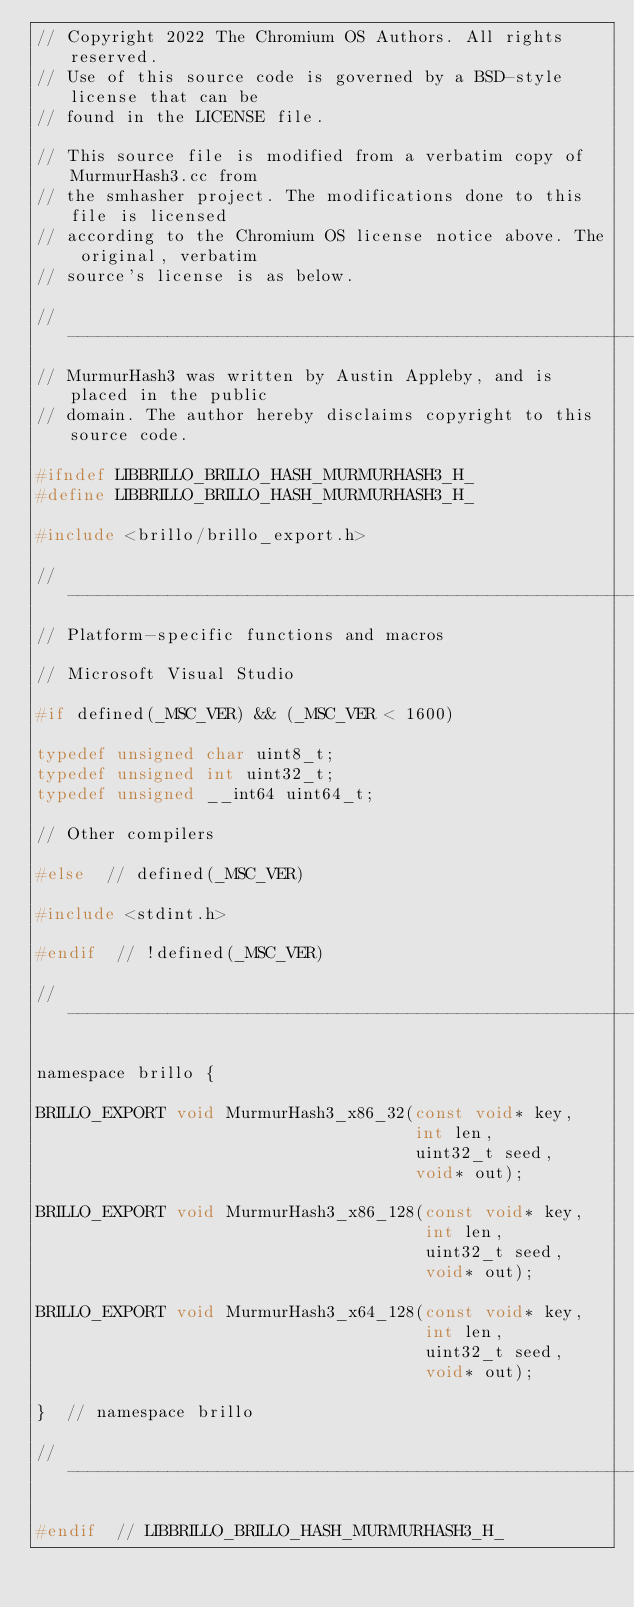Convert code to text. <code><loc_0><loc_0><loc_500><loc_500><_C_>// Copyright 2022 The Chromium OS Authors. All rights reserved.
// Use of this source code is governed by a BSD-style license that can be
// found in the LICENSE file.

// This source file is modified from a verbatim copy of MurmurHash3.cc from
// the smhasher project. The modifications done to this file is licensed
// according to the Chromium OS license notice above. The original, verbatim
// source's license is as below.

//-----------------------------------------------------------------------------
// MurmurHash3 was written by Austin Appleby, and is placed in the public
// domain. The author hereby disclaims copyright to this source code.

#ifndef LIBBRILLO_BRILLO_HASH_MURMURHASH3_H_
#define LIBBRILLO_BRILLO_HASH_MURMURHASH3_H_

#include <brillo/brillo_export.h>

//-----------------------------------------------------------------------------
// Platform-specific functions and macros

// Microsoft Visual Studio

#if defined(_MSC_VER) && (_MSC_VER < 1600)

typedef unsigned char uint8_t;
typedef unsigned int uint32_t;
typedef unsigned __int64 uint64_t;

// Other compilers

#else  // defined(_MSC_VER)

#include <stdint.h>

#endif  // !defined(_MSC_VER)

//-----------------------------------------------------------------------------

namespace brillo {

BRILLO_EXPORT void MurmurHash3_x86_32(const void* key,
                                      int len,
                                      uint32_t seed,
                                      void* out);

BRILLO_EXPORT void MurmurHash3_x86_128(const void* key,
                                       int len,
                                       uint32_t seed,
                                       void* out);

BRILLO_EXPORT void MurmurHash3_x64_128(const void* key,
                                       int len,
                                       uint32_t seed,
                                       void* out);

}  // namespace brillo

//-----------------------------------------------------------------------------

#endif  // LIBBRILLO_BRILLO_HASH_MURMURHASH3_H_
</code> 